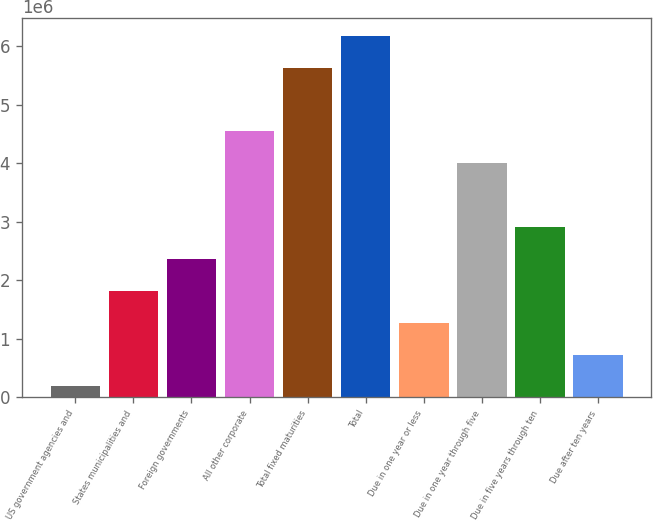<chart> <loc_0><loc_0><loc_500><loc_500><bar_chart><fcel>US government agencies and<fcel>States municipalities and<fcel>Foreign governments<fcel>All other corporate<fcel>Total fixed maturities<fcel>Total<fcel>Due in one year or less<fcel>Due in one year through five<fcel>Due in five years through ten<fcel>Due after ten years<nl><fcel>188320<fcel>1.82256e+06<fcel>2.36731e+06<fcel>4.5463e+06<fcel>5.6358e+06<fcel>6.18055e+06<fcel>1.27782e+06<fcel>4.00156e+06<fcel>2.91206e+06<fcel>733068<nl></chart> 